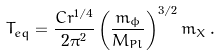<formula> <loc_0><loc_0><loc_500><loc_500>T _ { e q } = \frac { C r ^ { 1 / 4 } } { 2 \pi ^ { 2 } } \left ( \frac { m _ { \phi } } { M _ { P l } } \right ) ^ { 3 / 2 } m _ { X } \, .</formula> 